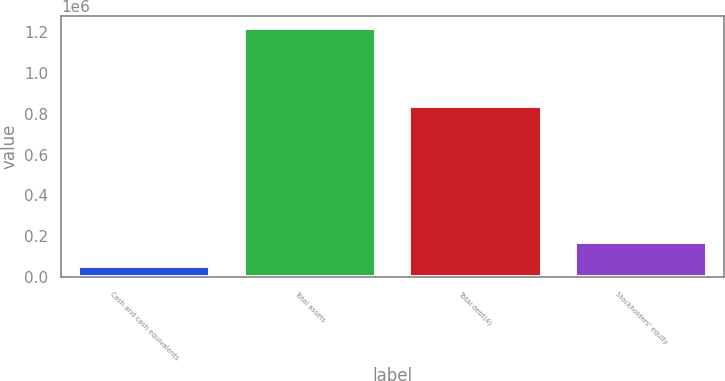<chart> <loc_0><loc_0><loc_500><loc_500><bar_chart><fcel>Cash and cash equivalents<fcel>Total assets<fcel>Total debt(4)<fcel>Stockholders' equity<nl><fcel>54974<fcel>1.21709e+06<fcel>839543<fcel>171186<nl></chart> 